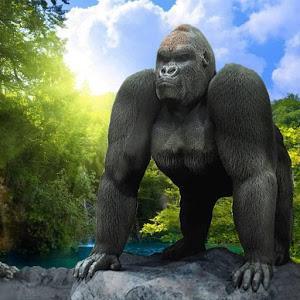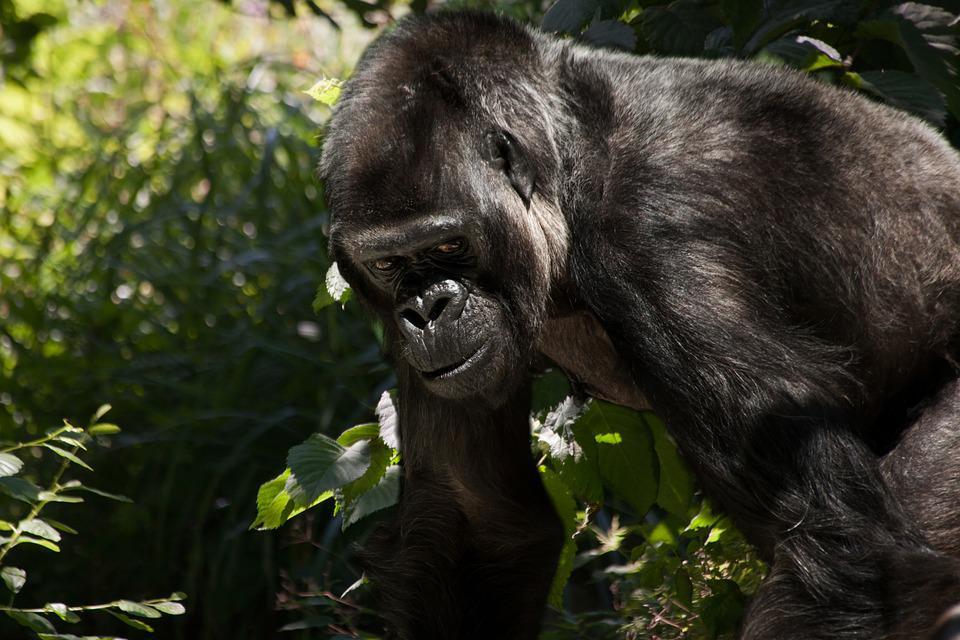The first image is the image on the left, the second image is the image on the right. Given the left and right images, does the statement "There is visible sky in one of the images." hold true? Answer yes or no. Yes. 